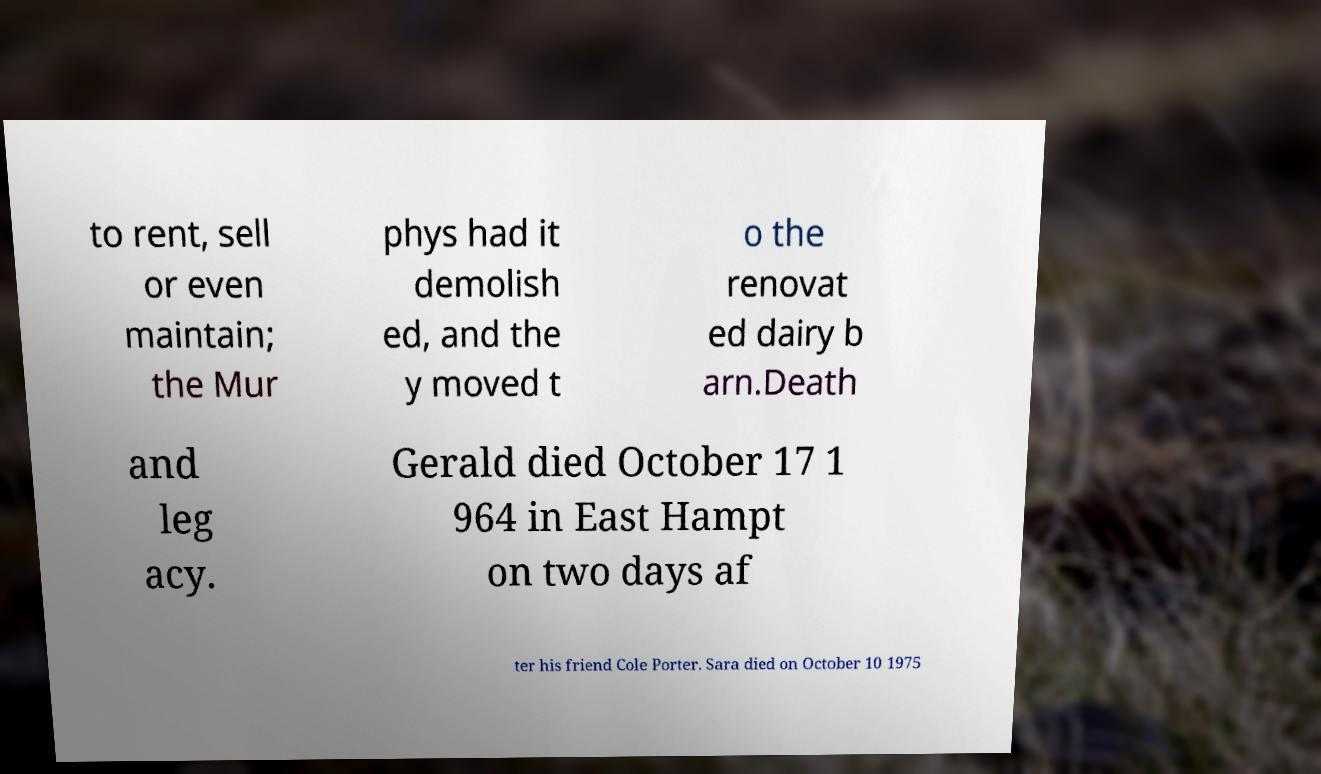I need the written content from this picture converted into text. Can you do that? to rent, sell or even maintain; the Mur phys had it demolish ed, and the y moved t o the renovat ed dairy b arn.Death and leg acy. Gerald died October 17 1 964 in East Hampt on two days af ter his friend Cole Porter. Sara died on October 10 1975 